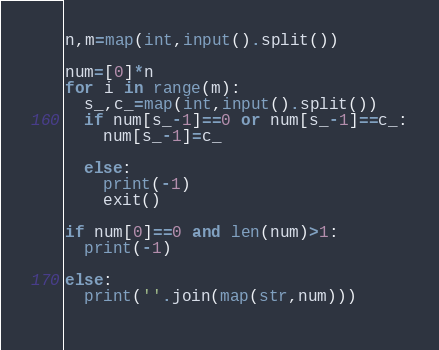Convert code to text. <code><loc_0><loc_0><loc_500><loc_500><_Python_>n,m=map(int,input().split())

num=[0]*n
for i in range(m):
  s_,c_=map(int,input().split())
  if num[s_-1]==0 or num[s_-1]==c_:
    num[s_-1]=c_
    
  else:
    print(-1)
    exit()
    
if num[0]==0 and len(num)>1:
  print(-1)
  
else:
  print(''.join(map(str,num)))
  </code> 